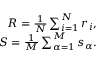Convert formula to latex. <formula><loc_0><loc_0><loc_500><loc_500>\begin{array} { r } { R = \frac { 1 } { N } \sum _ { i = 1 } ^ { N } r _ { i } , } \\ { S = \frac { 1 } { M } \sum _ { \alpha = 1 } ^ { M } s _ { \alpha } . } \end{array}</formula> 